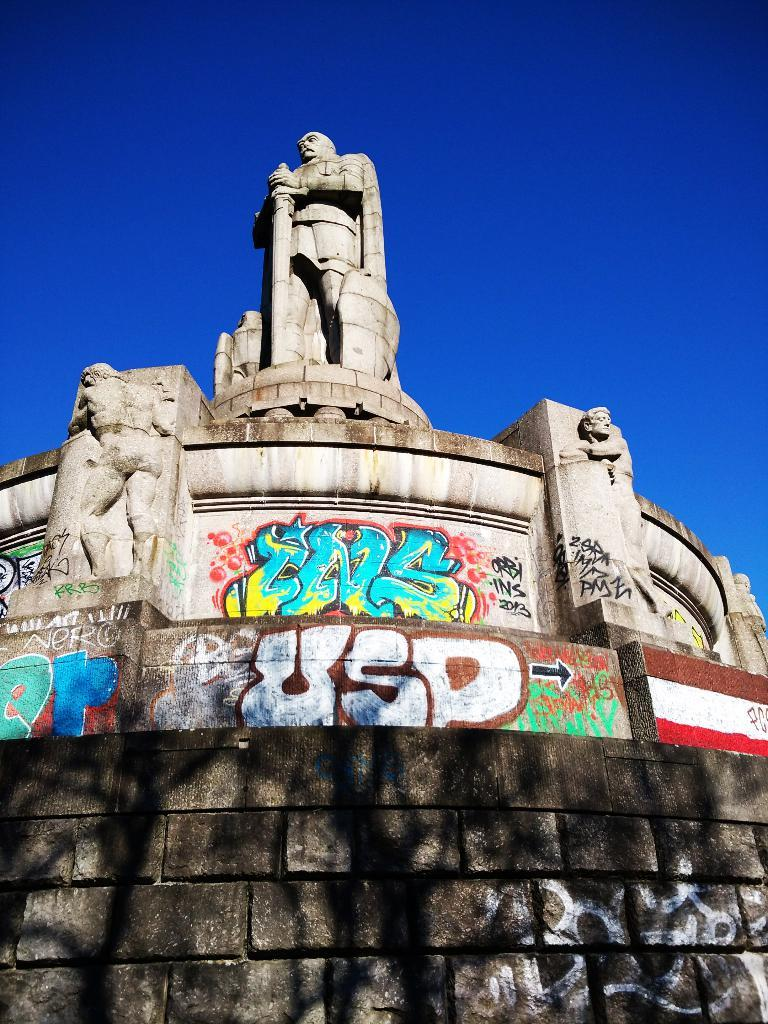What is the main subject in the image? There is a big statue in the image. What can be seen on the wall in the image? There is text and a flag painted on the wall in the image. What is the color of the sky in the image? The sky is blue and visible at the top of the image. How many friends are visible in the image? There are no friends visible in the image; it features a statue, text, and a flag on a wall. Can you see any veins or cobwebs on the statue in the image? There is no mention of veins or cobwebs on the statue in the image, and they are not visible in the provided facts. 